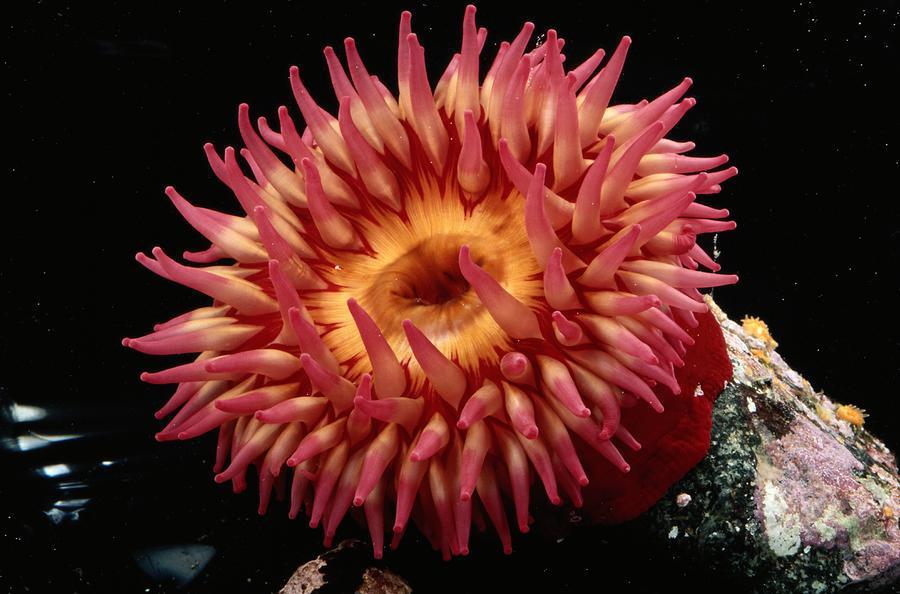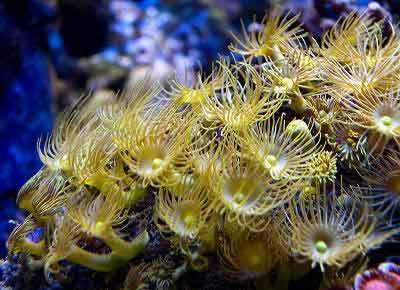The first image is the image on the left, the second image is the image on the right. For the images shown, is this caption "An image shows one anemone with ombre-toned reddish-tipped tendrils and a yellow center." true? Answer yes or no. Yes. 